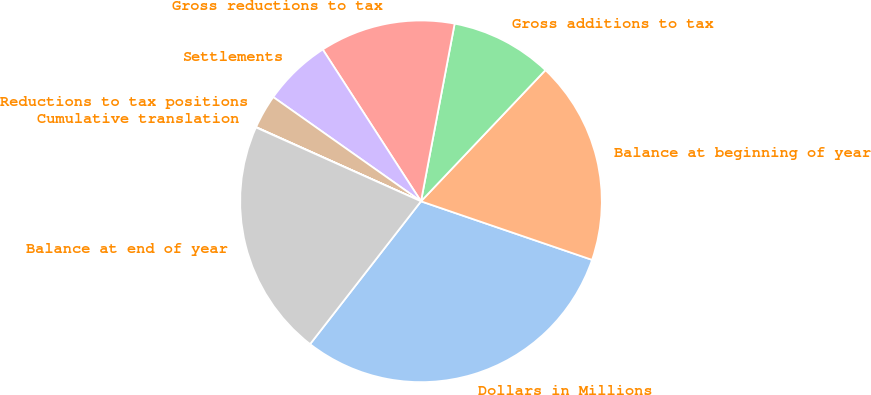Convert chart. <chart><loc_0><loc_0><loc_500><loc_500><pie_chart><fcel>Dollars in Millions<fcel>Balance at beginning of year<fcel>Gross additions to tax<fcel>Gross reductions to tax<fcel>Settlements<fcel>Reductions to tax positions<fcel>Cumulative translation<fcel>Balance at end of year<nl><fcel>30.26%<fcel>18.17%<fcel>9.1%<fcel>12.12%<fcel>6.08%<fcel>3.05%<fcel>0.03%<fcel>21.19%<nl></chart> 